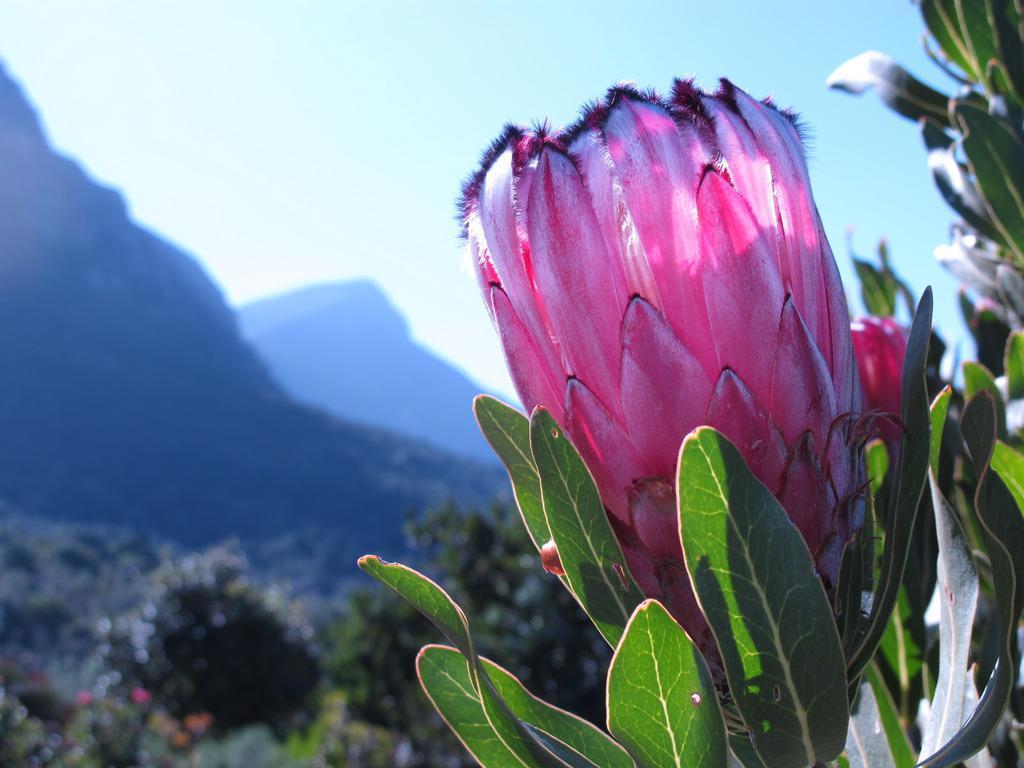How would you summarize this image in a sentence or two? In the center of the image we can see flower to a plant. In the background we can see trees, hills and sky. 